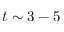Convert formula to latex. <formula><loc_0><loc_0><loc_500><loc_500>t \sim 3 - 5</formula> 